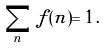Convert formula to latex. <formula><loc_0><loc_0><loc_500><loc_500>\sum _ { n } \, f ( n ) = 1 \, .</formula> 